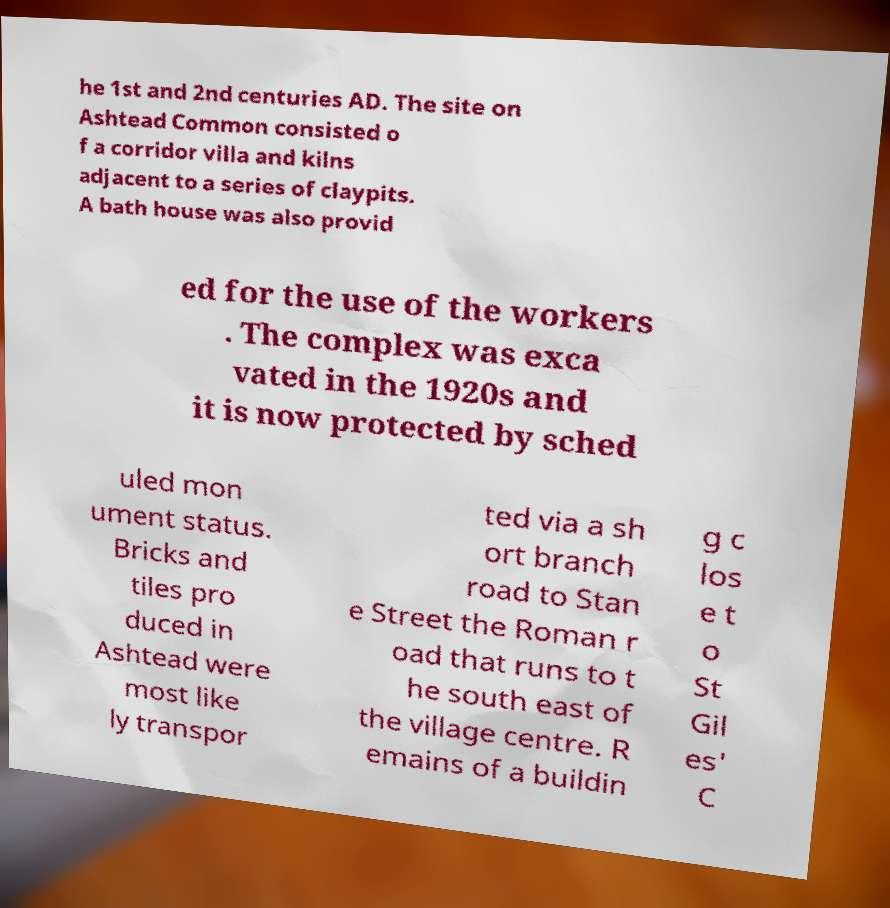Can you accurately transcribe the text from the provided image for me? he 1st and 2nd centuries AD. The site on Ashtead Common consisted o f a corridor villa and kilns adjacent to a series of claypits. A bath house was also provid ed for the use of the workers . The complex was exca vated in the 1920s and it is now protected by sched uled mon ument status. Bricks and tiles pro duced in Ashtead were most like ly transpor ted via a sh ort branch road to Stan e Street the Roman r oad that runs to t he south east of the village centre. R emains of a buildin g c los e t o St Gil es' C 